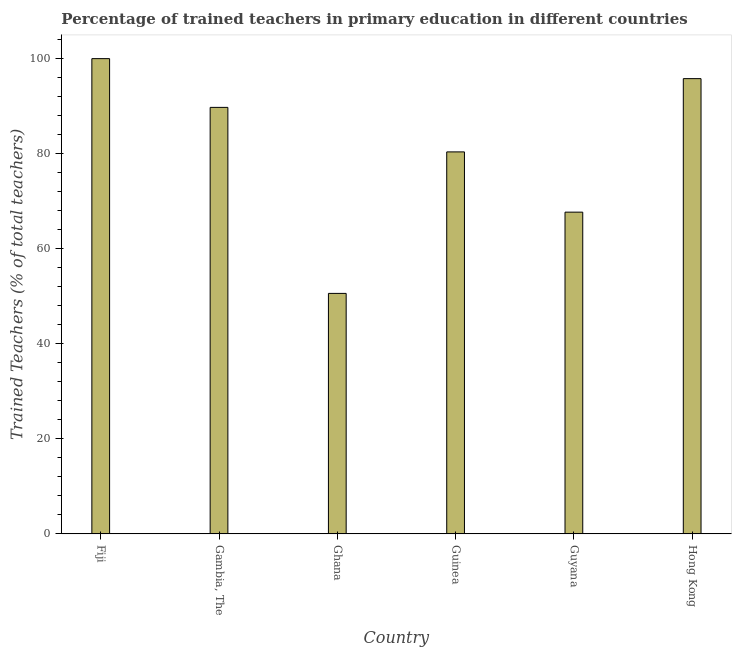Does the graph contain any zero values?
Keep it short and to the point. No. What is the title of the graph?
Your answer should be compact. Percentage of trained teachers in primary education in different countries. What is the label or title of the X-axis?
Keep it short and to the point. Country. What is the label or title of the Y-axis?
Offer a terse response. Trained Teachers (% of total teachers). What is the percentage of trained teachers in Gambia, The?
Offer a terse response. 89.74. Across all countries, what is the maximum percentage of trained teachers?
Provide a succinct answer. 100. Across all countries, what is the minimum percentage of trained teachers?
Your answer should be compact. 50.6. In which country was the percentage of trained teachers maximum?
Offer a terse response. Fiji. What is the sum of the percentage of trained teachers?
Your answer should be very brief. 484.21. What is the difference between the percentage of trained teachers in Gambia, The and Guyana?
Offer a very short reply. 22.05. What is the average percentage of trained teachers per country?
Offer a very short reply. 80.7. What is the median percentage of trained teachers?
Ensure brevity in your answer.  85.06. What is the ratio of the percentage of trained teachers in Fiji to that in Guyana?
Provide a succinct answer. 1.48. Is the difference between the percentage of trained teachers in Ghana and Guyana greater than the difference between any two countries?
Keep it short and to the point. No. What is the difference between the highest and the second highest percentage of trained teachers?
Your answer should be compact. 4.21. Is the sum of the percentage of trained teachers in Fiji and Guinea greater than the maximum percentage of trained teachers across all countries?
Your response must be concise. Yes. What is the difference between the highest and the lowest percentage of trained teachers?
Offer a terse response. 49.4. How many bars are there?
Your answer should be compact. 6. Are all the bars in the graph horizontal?
Make the answer very short. No. How many countries are there in the graph?
Your response must be concise. 6. What is the Trained Teachers (% of total teachers) of Fiji?
Give a very brief answer. 100. What is the Trained Teachers (% of total teachers) of Gambia, The?
Provide a short and direct response. 89.74. What is the Trained Teachers (% of total teachers) of Ghana?
Ensure brevity in your answer.  50.6. What is the Trained Teachers (% of total teachers) of Guinea?
Your response must be concise. 80.38. What is the Trained Teachers (% of total teachers) in Guyana?
Provide a short and direct response. 67.7. What is the Trained Teachers (% of total teachers) in Hong Kong?
Offer a terse response. 95.79. What is the difference between the Trained Teachers (% of total teachers) in Fiji and Gambia, The?
Offer a very short reply. 10.26. What is the difference between the Trained Teachers (% of total teachers) in Fiji and Ghana?
Ensure brevity in your answer.  49.4. What is the difference between the Trained Teachers (% of total teachers) in Fiji and Guinea?
Offer a terse response. 19.62. What is the difference between the Trained Teachers (% of total teachers) in Fiji and Guyana?
Make the answer very short. 32.3. What is the difference between the Trained Teachers (% of total teachers) in Fiji and Hong Kong?
Your response must be concise. 4.21. What is the difference between the Trained Teachers (% of total teachers) in Gambia, The and Ghana?
Your answer should be very brief. 39.14. What is the difference between the Trained Teachers (% of total teachers) in Gambia, The and Guinea?
Provide a short and direct response. 9.37. What is the difference between the Trained Teachers (% of total teachers) in Gambia, The and Guyana?
Offer a very short reply. 22.05. What is the difference between the Trained Teachers (% of total teachers) in Gambia, The and Hong Kong?
Your answer should be compact. -6.05. What is the difference between the Trained Teachers (% of total teachers) in Ghana and Guinea?
Your answer should be compact. -29.78. What is the difference between the Trained Teachers (% of total teachers) in Ghana and Guyana?
Provide a succinct answer. -17.1. What is the difference between the Trained Teachers (% of total teachers) in Ghana and Hong Kong?
Offer a terse response. -45.19. What is the difference between the Trained Teachers (% of total teachers) in Guinea and Guyana?
Make the answer very short. 12.68. What is the difference between the Trained Teachers (% of total teachers) in Guinea and Hong Kong?
Ensure brevity in your answer.  -15.41. What is the difference between the Trained Teachers (% of total teachers) in Guyana and Hong Kong?
Provide a short and direct response. -28.09. What is the ratio of the Trained Teachers (% of total teachers) in Fiji to that in Gambia, The?
Offer a terse response. 1.11. What is the ratio of the Trained Teachers (% of total teachers) in Fiji to that in Ghana?
Give a very brief answer. 1.98. What is the ratio of the Trained Teachers (% of total teachers) in Fiji to that in Guinea?
Offer a very short reply. 1.24. What is the ratio of the Trained Teachers (% of total teachers) in Fiji to that in Guyana?
Make the answer very short. 1.48. What is the ratio of the Trained Teachers (% of total teachers) in Fiji to that in Hong Kong?
Provide a succinct answer. 1.04. What is the ratio of the Trained Teachers (% of total teachers) in Gambia, The to that in Ghana?
Your answer should be compact. 1.77. What is the ratio of the Trained Teachers (% of total teachers) in Gambia, The to that in Guinea?
Your answer should be compact. 1.12. What is the ratio of the Trained Teachers (% of total teachers) in Gambia, The to that in Guyana?
Your response must be concise. 1.33. What is the ratio of the Trained Teachers (% of total teachers) in Gambia, The to that in Hong Kong?
Offer a terse response. 0.94. What is the ratio of the Trained Teachers (% of total teachers) in Ghana to that in Guinea?
Ensure brevity in your answer.  0.63. What is the ratio of the Trained Teachers (% of total teachers) in Ghana to that in Guyana?
Provide a short and direct response. 0.75. What is the ratio of the Trained Teachers (% of total teachers) in Ghana to that in Hong Kong?
Keep it short and to the point. 0.53. What is the ratio of the Trained Teachers (% of total teachers) in Guinea to that in Guyana?
Offer a terse response. 1.19. What is the ratio of the Trained Teachers (% of total teachers) in Guinea to that in Hong Kong?
Ensure brevity in your answer.  0.84. What is the ratio of the Trained Teachers (% of total teachers) in Guyana to that in Hong Kong?
Keep it short and to the point. 0.71. 